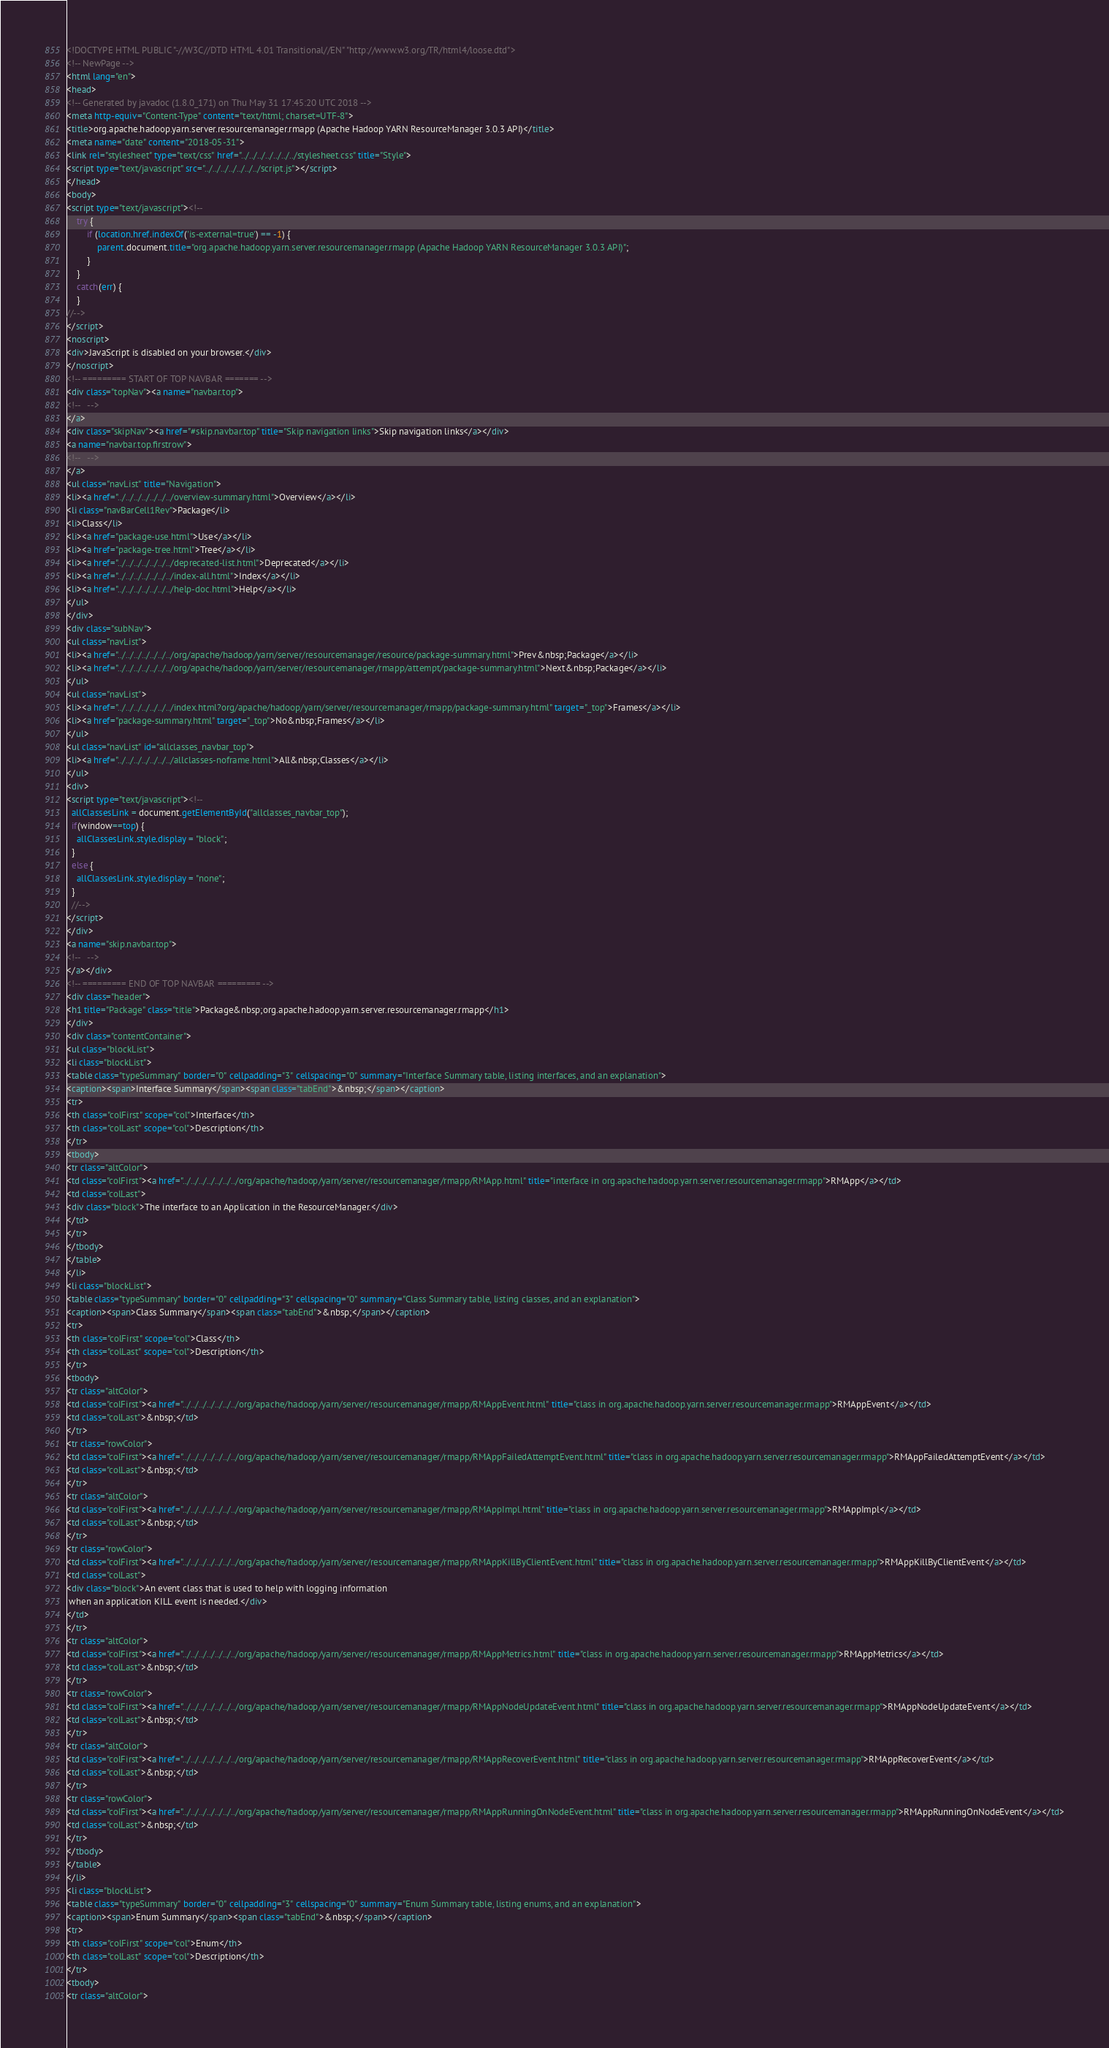<code> <loc_0><loc_0><loc_500><loc_500><_HTML_><!DOCTYPE HTML PUBLIC "-//W3C//DTD HTML 4.01 Transitional//EN" "http://www.w3.org/TR/html4/loose.dtd">
<!-- NewPage -->
<html lang="en">
<head>
<!-- Generated by javadoc (1.8.0_171) on Thu May 31 17:45:20 UTC 2018 -->
<meta http-equiv="Content-Type" content="text/html; charset=UTF-8">
<title>org.apache.hadoop.yarn.server.resourcemanager.rmapp (Apache Hadoop YARN ResourceManager 3.0.3 API)</title>
<meta name="date" content="2018-05-31">
<link rel="stylesheet" type="text/css" href="../../../../../../../stylesheet.css" title="Style">
<script type="text/javascript" src="../../../../../../../script.js"></script>
</head>
<body>
<script type="text/javascript"><!--
    try {
        if (location.href.indexOf('is-external=true') == -1) {
            parent.document.title="org.apache.hadoop.yarn.server.resourcemanager.rmapp (Apache Hadoop YARN ResourceManager 3.0.3 API)";
        }
    }
    catch(err) {
    }
//-->
</script>
<noscript>
<div>JavaScript is disabled on your browser.</div>
</noscript>
<!-- ========= START OF TOP NAVBAR ======= -->
<div class="topNav"><a name="navbar.top">
<!--   -->
</a>
<div class="skipNav"><a href="#skip.navbar.top" title="Skip navigation links">Skip navigation links</a></div>
<a name="navbar.top.firstrow">
<!--   -->
</a>
<ul class="navList" title="Navigation">
<li><a href="../../../../../../../overview-summary.html">Overview</a></li>
<li class="navBarCell1Rev">Package</li>
<li>Class</li>
<li><a href="package-use.html">Use</a></li>
<li><a href="package-tree.html">Tree</a></li>
<li><a href="../../../../../../../deprecated-list.html">Deprecated</a></li>
<li><a href="../../../../../../../index-all.html">Index</a></li>
<li><a href="../../../../../../../help-doc.html">Help</a></li>
</ul>
</div>
<div class="subNav">
<ul class="navList">
<li><a href="../../../../../../../org/apache/hadoop/yarn/server/resourcemanager/resource/package-summary.html">Prev&nbsp;Package</a></li>
<li><a href="../../../../../../../org/apache/hadoop/yarn/server/resourcemanager/rmapp/attempt/package-summary.html">Next&nbsp;Package</a></li>
</ul>
<ul class="navList">
<li><a href="../../../../../../../index.html?org/apache/hadoop/yarn/server/resourcemanager/rmapp/package-summary.html" target="_top">Frames</a></li>
<li><a href="package-summary.html" target="_top">No&nbsp;Frames</a></li>
</ul>
<ul class="navList" id="allclasses_navbar_top">
<li><a href="../../../../../../../allclasses-noframe.html">All&nbsp;Classes</a></li>
</ul>
<div>
<script type="text/javascript"><!--
  allClassesLink = document.getElementById("allclasses_navbar_top");
  if(window==top) {
    allClassesLink.style.display = "block";
  }
  else {
    allClassesLink.style.display = "none";
  }
  //-->
</script>
</div>
<a name="skip.navbar.top">
<!--   -->
</a></div>
<!-- ========= END OF TOP NAVBAR ========= -->
<div class="header">
<h1 title="Package" class="title">Package&nbsp;org.apache.hadoop.yarn.server.resourcemanager.rmapp</h1>
</div>
<div class="contentContainer">
<ul class="blockList">
<li class="blockList">
<table class="typeSummary" border="0" cellpadding="3" cellspacing="0" summary="Interface Summary table, listing interfaces, and an explanation">
<caption><span>Interface Summary</span><span class="tabEnd">&nbsp;</span></caption>
<tr>
<th class="colFirst" scope="col">Interface</th>
<th class="colLast" scope="col">Description</th>
</tr>
<tbody>
<tr class="altColor">
<td class="colFirst"><a href="../../../../../../../org/apache/hadoop/yarn/server/resourcemanager/rmapp/RMApp.html" title="interface in org.apache.hadoop.yarn.server.resourcemanager.rmapp">RMApp</a></td>
<td class="colLast">
<div class="block">The interface to an Application in the ResourceManager.</div>
</td>
</tr>
</tbody>
</table>
</li>
<li class="blockList">
<table class="typeSummary" border="0" cellpadding="3" cellspacing="0" summary="Class Summary table, listing classes, and an explanation">
<caption><span>Class Summary</span><span class="tabEnd">&nbsp;</span></caption>
<tr>
<th class="colFirst" scope="col">Class</th>
<th class="colLast" scope="col">Description</th>
</tr>
<tbody>
<tr class="altColor">
<td class="colFirst"><a href="../../../../../../../org/apache/hadoop/yarn/server/resourcemanager/rmapp/RMAppEvent.html" title="class in org.apache.hadoop.yarn.server.resourcemanager.rmapp">RMAppEvent</a></td>
<td class="colLast">&nbsp;</td>
</tr>
<tr class="rowColor">
<td class="colFirst"><a href="../../../../../../../org/apache/hadoop/yarn/server/resourcemanager/rmapp/RMAppFailedAttemptEvent.html" title="class in org.apache.hadoop.yarn.server.resourcemanager.rmapp">RMAppFailedAttemptEvent</a></td>
<td class="colLast">&nbsp;</td>
</tr>
<tr class="altColor">
<td class="colFirst"><a href="../../../../../../../org/apache/hadoop/yarn/server/resourcemanager/rmapp/RMAppImpl.html" title="class in org.apache.hadoop.yarn.server.resourcemanager.rmapp">RMAppImpl</a></td>
<td class="colLast">&nbsp;</td>
</tr>
<tr class="rowColor">
<td class="colFirst"><a href="../../../../../../../org/apache/hadoop/yarn/server/resourcemanager/rmapp/RMAppKillByClientEvent.html" title="class in org.apache.hadoop.yarn.server.resourcemanager.rmapp">RMAppKillByClientEvent</a></td>
<td class="colLast">
<div class="block">An event class that is used to help with logging information
 when an application KILL event is needed.</div>
</td>
</tr>
<tr class="altColor">
<td class="colFirst"><a href="../../../../../../../org/apache/hadoop/yarn/server/resourcemanager/rmapp/RMAppMetrics.html" title="class in org.apache.hadoop.yarn.server.resourcemanager.rmapp">RMAppMetrics</a></td>
<td class="colLast">&nbsp;</td>
</tr>
<tr class="rowColor">
<td class="colFirst"><a href="../../../../../../../org/apache/hadoop/yarn/server/resourcemanager/rmapp/RMAppNodeUpdateEvent.html" title="class in org.apache.hadoop.yarn.server.resourcemanager.rmapp">RMAppNodeUpdateEvent</a></td>
<td class="colLast">&nbsp;</td>
</tr>
<tr class="altColor">
<td class="colFirst"><a href="../../../../../../../org/apache/hadoop/yarn/server/resourcemanager/rmapp/RMAppRecoverEvent.html" title="class in org.apache.hadoop.yarn.server.resourcemanager.rmapp">RMAppRecoverEvent</a></td>
<td class="colLast">&nbsp;</td>
</tr>
<tr class="rowColor">
<td class="colFirst"><a href="../../../../../../../org/apache/hadoop/yarn/server/resourcemanager/rmapp/RMAppRunningOnNodeEvent.html" title="class in org.apache.hadoop.yarn.server.resourcemanager.rmapp">RMAppRunningOnNodeEvent</a></td>
<td class="colLast">&nbsp;</td>
</tr>
</tbody>
</table>
</li>
<li class="blockList">
<table class="typeSummary" border="0" cellpadding="3" cellspacing="0" summary="Enum Summary table, listing enums, and an explanation">
<caption><span>Enum Summary</span><span class="tabEnd">&nbsp;</span></caption>
<tr>
<th class="colFirst" scope="col">Enum</th>
<th class="colLast" scope="col">Description</th>
</tr>
<tbody>
<tr class="altColor"></code> 